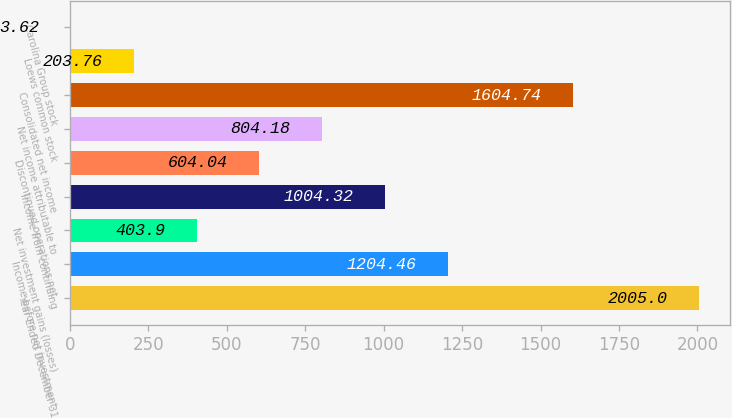<chart> <loc_0><loc_0><loc_500><loc_500><bar_chart><fcel>Year Ended December 31<fcel>Income before net investment<fcel>Net investment gains (losses)<fcel>Income from continuing<fcel>Discontinued operations net<fcel>Net income attributable to<fcel>Consolidated net income<fcel>Loews common stock<fcel>Carolina Group stock<nl><fcel>2005<fcel>1204.46<fcel>403.9<fcel>1004.32<fcel>604.04<fcel>804.18<fcel>1604.74<fcel>203.76<fcel>3.62<nl></chart> 